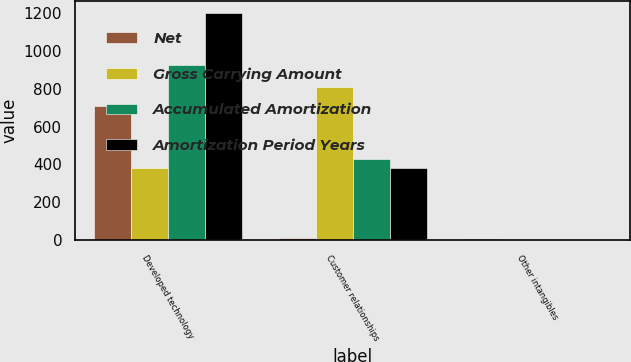<chart> <loc_0><loc_0><loc_500><loc_500><stacked_bar_chart><ecel><fcel>Developed technology<fcel>Customer relationships<fcel>Other intangibles<nl><fcel>Net<fcel>710<fcel>8<fcel>5<nl><fcel>Gross Carrying Amount<fcel>379<fcel>810<fcel>3<nl><fcel>Accumulated Amortization<fcel>928<fcel>431<fcel>2<nl><fcel>Amortization Period Years<fcel>1203<fcel>379<fcel>1<nl></chart> 